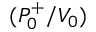Convert formula to latex. <formula><loc_0><loc_0><loc_500><loc_500>( P _ { 0 } ^ { + } / V _ { 0 } )</formula> 